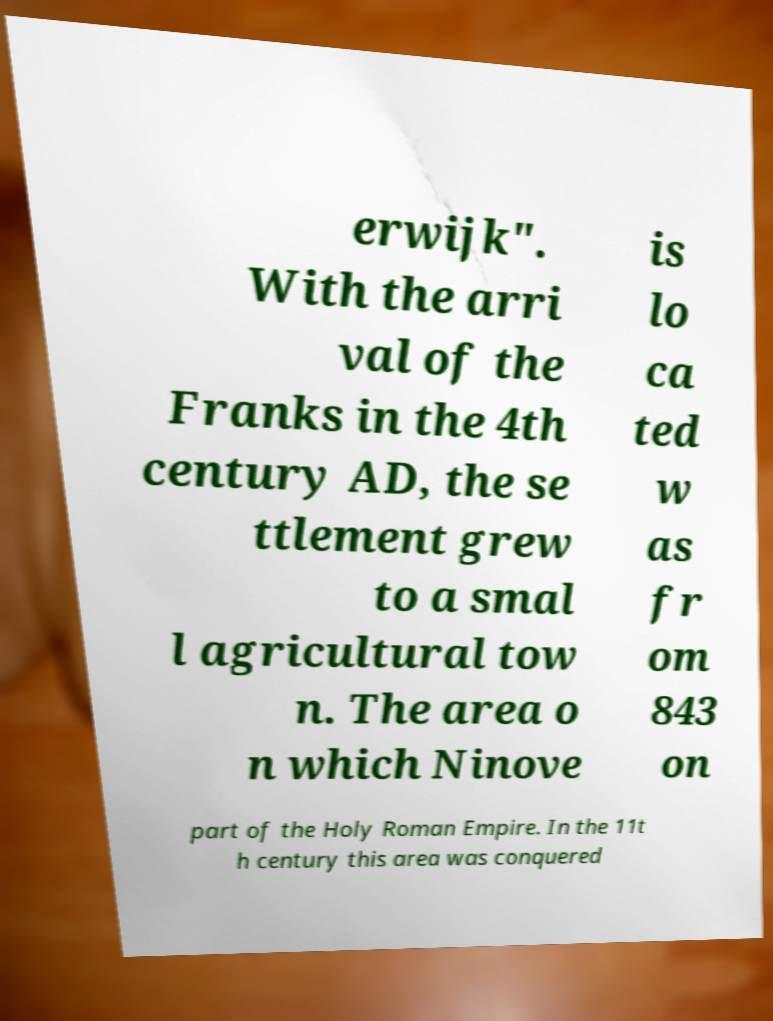Please identify and transcribe the text found in this image. erwijk". With the arri val of the Franks in the 4th century AD, the se ttlement grew to a smal l agricultural tow n. The area o n which Ninove is lo ca ted w as fr om 843 on part of the Holy Roman Empire. In the 11t h century this area was conquered 